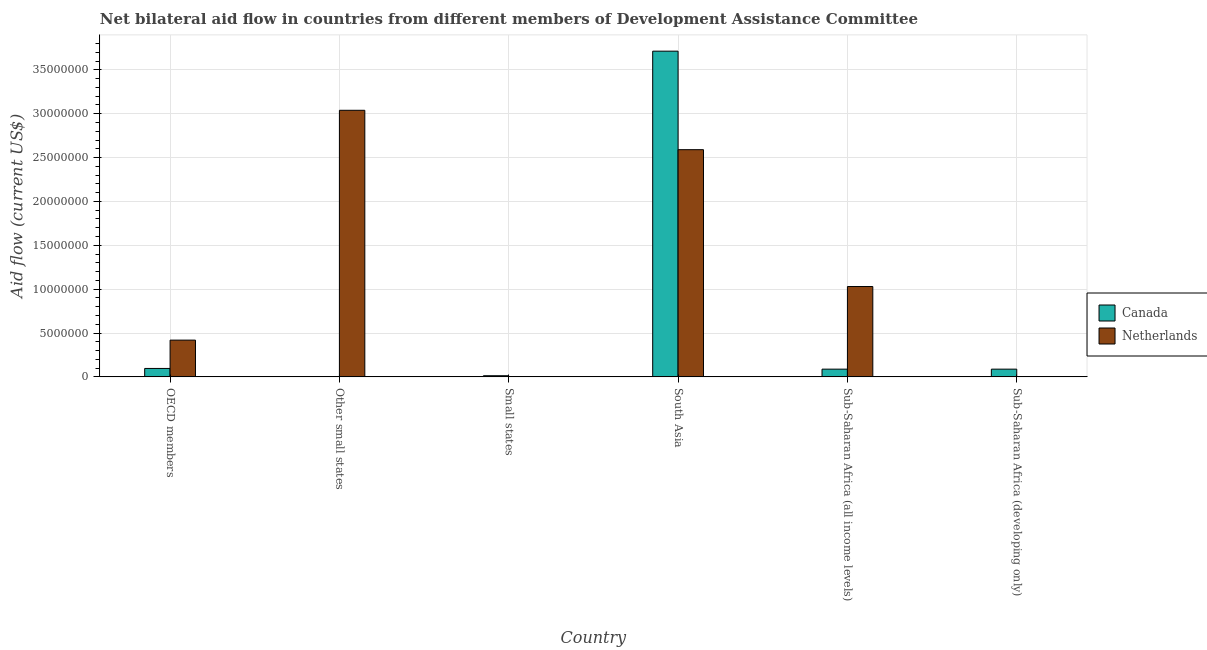How many different coloured bars are there?
Your response must be concise. 2. What is the label of the 2nd group of bars from the left?
Your response must be concise. Other small states. In how many cases, is the number of bars for a given country not equal to the number of legend labels?
Ensure brevity in your answer.  2. What is the amount of aid given by netherlands in Small states?
Offer a terse response. 0. Across all countries, what is the maximum amount of aid given by canada?
Provide a short and direct response. 3.71e+07. What is the total amount of aid given by netherlands in the graph?
Your answer should be very brief. 7.08e+07. What is the difference between the amount of aid given by canada in Small states and that in Sub-Saharan Africa (all income levels)?
Give a very brief answer. -7.50e+05. What is the difference between the amount of aid given by netherlands in Sub-Saharan Africa (developing only) and the amount of aid given by canada in South Asia?
Ensure brevity in your answer.  -3.71e+07. What is the average amount of aid given by canada per country?
Provide a succinct answer. 6.67e+06. What is the difference between the amount of aid given by canada and amount of aid given by netherlands in Other small states?
Your response must be concise. -3.04e+07. What is the ratio of the amount of aid given by canada in Small states to that in Sub-Saharan Africa (developing only)?
Provide a short and direct response. 0.15. Is the amount of aid given by canada in Sub-Saharan Africa (all income levels) less than that in Sub-Saharan Africa (developing only)?
Your answer should be very brief. No. Is the difference between the amount of aid given by netherlands in OECD members and Other small states greater than the difference between the amount of aid given by canada in OECD members and Other small states?
Your answer should be compact. No. What is the difference between the highest and the second highest amount of aid given by canada?
Keep it short and to the point. 3.62e+07. What is the difference between the highest and the lowest amount of aid given by canada?
Your response must be concise. 3.71e+07. In how many countries, is the amount of aid given by canada greater than the average amount of aid given by canada taken over all countries?
Offer a very short reply. 1. Is the sum of the amount of aid given by canada in Small states and Sub-Saharan Africa (developing only) greater than the maximum amount of aid given by netherlands across all countries?
Your answer should be compact. No. What is the difference between two consecutive major ticks on the Y-axis?
Ensure brevity in your answer.  5.00e+06. How many legend labels are there?
Your answer should be compact. 2. What is the title of the graph?
Make the answer very short. Net bilateral aid flow in countries from different members of Development Assistance Committee. What is the label or title of the X-axis?
Provide a succinct answer. Country. What is the Aid flow (current US$) in Canada in OECD members?
Your response must be concise. 9.60e+05. What is the Aid flow (current US$) in Netherlands in OECD members?
Your response must be concise. 4.19e+06. What is the Aid flow (current US$) in Netherlands in Other small states?
Your answer should be compact. 3.04e+07. What is the Aid flow (current US$) in Canada in Small states?
Make the answer very short. 1.30e+05. What is the Aid flow (current US$) of Netherlands in Small states?
Make the answer very short. 0. What is the Aid flow (current US$) in Canada in South Asia?
Your answer should be very brief. 3.71e+07. What is the Aid flow (current US$) of Netherlands in South Asia?
Provide a succinct answer. 2.59e+07. What is the Aid flow (current US$) in Canada in Sub-Saharan Africa (all income levels)?
Offer a very short reply. 8.80e+05. What is the Aid flow (current US$) of Netherlands in Sub-Saharan Africa (all income levels)?
Provide a short and direct response. 1.03e+07. What is the Aid flow (current US$) in Canada in Sub-Saharan Africa (developing only)?
Offer a very short reply. 8.80e+05. What is the Aid flow (current US$) in Netherlands in Sub-Saharan Africa (developing only)?
Provide a succinct answer. 0. Across all countries, what is the maximum Aid flow (current US$) of Canada?
Keep it short and to the point. 3.71e+07. Across all countries, what is the maximum Aid flow (current US$) in Netherlands?
Give a very brief answer. 3.04e+07. Across all countries, what is the minimum Aid flow (current US$) of Canada?
Offer a terse response. 3.00e+04. Across all countries, what is the minimum Aid flow (current US$) in Netherlands?
Your response must be concise. 0. What is the total Aid flow (current US$) of Canada in the graph?
Provide a succinct answer. 4.00e+07. What is the total Aid flow (current US$) in Netherlands in the graph?
Make the answer very short. 7.08e+07. What is the difference between the Aid flow (current US$) in Canada in OECD members and that in Other small states?
Ensure brevity in your answer.  9.30e+05. What is the difference between the Aid flow (current US$) of Netherlands in OECD members and that in Other small states?
Keep it short and to the point. -2.62e+07. What is the difference between the Aid flow (current US$) in Canada in OECD members and that in Small states?
Make the answer very short. 8.30e+05. What is the difference between the Aid flow (current US$) of Canada in OECD members and that in South Asia?
Your answer should be compact. -3.62e+07. What is the difference between the Aid flow (current US$) of Netherlands in OECD members and that in South Asia?
Keep it short and to the point. -2.17e+07. What is the difference between the Aid flow (current US$) in Canada in OECD members and that in Sub-Saharan Africa (all income levels)?
Provide a short and direct response. 8.00e+04. What is the difference between the Aid flow (current US$) of Netherlands in OECD members and that in Sub-Saharan Africa (all income levels)?
Keep it short and to the point. -6.11e+06. What is the difference between the Aid flow (current US$) in Canada in Other small states and that in Small states?
Your response must be concise. -1.00e+05. What is the difference between the Aid flow (current US$) in Canada in Other small states and that in South Asia?
Offer a terse response. -3.71e+07. What is the difference between the Aid flow (current US$) in Netherlands in Other small states and that in South Asia?
Give a very brief answer. 4.49e+06. What is the difference between the Aid flow (current US$) in Canada in Other small states and that in Sub-Saharan Africa (all income levels)?
Ensure brevity in your answer.  -8.50e+05. What is the difference between the Aid flow (current US$) in Netherlands in Other small states and that in Sub-Saharan Africa (all income levels)?
Your response must be concise. 2.01e+07. What is the difference between the Aid flow (current US$) of Canada in Other small states and that in Sub-Saharan Africa (developing only)?
Make the answer very short. -8.50e+05. What is the difference between the Aid flow (current US$) of Canada in Small states and that in South Asia?
Make the answer very short. -3.70e+07. What is the difference between the Aid flow (current US$) of Canada in Small states and that in Sub-Saharan Africa (all income levels)?
Keep it short and to the point. -7.50e+05. What is the difference between the Aid flow (current US$) of Canada in Small states and that in Sub-Saharan Africa (developing only)?
Ensure brevity in your answer.  -7.50e+05. What is the difference between the Aid flow (current US$) in Canada in South Asia and that in Sub-Saharan Africa (all income levels)?
Ensure brevity in your answer.  3.62e+07. What is the difference between the Aid flow (current US$) of Netherlands in South Asia and that in Sub-Saharan Africa (all income levels)?
Provide a succinct answer. 1.56e+07. What is the difference between the Aid flow (current US$) of Canada in South Asia and that in Sub-Saharan Africa (developing only)?
Give a very brief answer. 3.62e+07. What is the difference between the Aid flow (current US$) in Canada in Sub-Saharan Africa (all income levels) and that in Sub-Saharan Africa (developing only)?
Provide a short and direct response. 0. What is the difference between the Aid flow (current US$) in Canada in OECD members and the Aid flow (current US$) in Netherlands in Other small states?
Your answer should be very brief. -2.94e+07. What is the difference between the Aid flow (current US$) in Canada in OECD members and the Aid flow (current US$) in Netherlands in South Asia?
Keep it short and to the point. -2.49e+07. What is the difference between the Aid flow (current US$) of Canada in OECD members and the Aid flow (current US$) of Netherlands in Sub-Saharan Africa (all income levels)?
Provide a short and direct response. -9.34e+06. What is the difference between the Aid flow (current US$) of Canada in Other small states and the Aid flow (current US$) of Netherlands in South Asia?
Provide a succinct answer. -2.59e+07. What is the difference between the Aid flow (current US$) of Canada in Other small states and the Aid flow (current US$) of Netherlands in Sub-Saharan Africa (all income levels)?
Provide a succinct answer. -1.03e+07. What is the difference between the Aid flow (current US$) of Canada in Small states and the Aid flow (current US$) of Netherlands in South Asia?
Give a very brief answer. -2.58e+07. What is the difference between the Aid flow (current US$) in Canada in Small states and the Aid flow (current US$) in Netherlands in Sub-Saharan Africa (all income levels)?
Give a very brief answer. -1.02e+07. What is the difference between the Aid flow (current US$) in Canada in South Asia and the Aid flow (current US$) in Netherlands in Sub-Saharan Africa (all income levels)?
Give a very brief answer. 2.68e+07. What is the average Aid flow (current US$) in Canada per country?
Offer a very short reply. 6.67e+06. What is the average Aid flow (current US$) in Netherlands per country?
Your answer should be very brief. 1.18e+07. What is the difference between the Aid flow (current US$) in Canada and Aid flow (current US$) in Netherlands in OECD members?
Provide a short and direct response. -3.23e+06. What is the difference between the Aid flow (current US$) in Canada and Aid flow (current US$) in Netherlands in Other small states?
Make the answer very short. -3.04e+07. What is the difference between the Aid flow (current US$) of Canada and Aid flow (current US$) of Netherlands in South Asia?
Your answer should be compact. 1.12e+07. What is the difference between the Aid flow (current US$) in Canada and Aid flow (current US$) in Netherlands in Sub-Saharan Africa (all income levels)?
Your answer should be very brief. -9.42e+06. What is the ratio of the Aid flow (current US$) in Canada in OECD members to that in Other small states?
Make the answer very short. 32. What is the ratio of the Aid flow (current US$) in Netherlands in OECD members to that in Other small states?
Offer a terse response. 0.14. What is the ratio of the Aid flow (current US$) in Canada in OECD members to that in Small states?
Make the answer very short. 7.38. What is the ratio of the Aid flow (current US$) in Canada in OECD members to that in South Asia?
Provide a succinct answer. 0.03. What is the ratio of the Aid flow (current US$) of Netherlands in OECD members to that in South Asia?
Ensure brevity in your answer.  0.16. What is the ratio of the Aid flow (current US$) in Netherlands in OECD members to that in Sub-Saharan Africa (all income levels)?
Your response must be concise. 0.41. What is the ratio of the Aid flow (current US$) of Canada in Other small states to that in Small states?
Give a very brief answer. 0.23. What is the ratio of the Aid flow (current US$) of Canada in Other small states to that in South Asia?
Provide a short and direct response. 0. What is the ratio of the Aid flow (current US$) in Netherlands in Other small states to that in South Asia?
Offer a terse response. 1.17. What is the ratio of the Aid flow (current US$) in Canada in Other small states to that in Sub-Saharan Africa (all income levels)?
Keep it short and to the point. 0.03. What is the ratio of the Aid flow (current US$) of Netherlands in Other small states to that in Sub-Saharan Africa (all income levels)?
Your answer should be compact. 2.95. What is the ratio of the Aid flow (current US$) in Canada in Other small states to that in Sub-Saharan Africa (developing only)?
Provide a succinct answer. 0.03. What is the ratio of the Aid flow (current US$) of Canada in Small states to that in South Asia?
Your response must be concise. 0. What is the ratio of the Aid flow (current US$) in Canada in Small states to that in Sub-Saharan Africa (all income levels)?
Provide a succinct answer. 0.15. What is the ratio of the Aid flow (current US$) in Canada in Small states to that in Sub-Saharan Africa (developing only)?
Ensure brevity in your answer.  0.15. What is the ratio of the Aid flow (current US$) in Canada in South Asia to that in Sub-Saharan Africa (all income levels)?
Offer a very short reply. 42.19. What is the ratio of the Aid flow (current US$) of Netherlands in South Asia to that in Sub-Saharan Africa (all income levels)?
Provide a short and direct response. 2.51. What is the ratio of the Aid flow (current US$) of Canada in South Asia to that in Sub-Saharan Africa (developing only)?
Make the answer very short. 42.19. What is the difference between the highest and the second highest Aid flow (current US$) of Canada?
Ensure brevity in your answer.  3.62e+07. What is the difference between the highest and the second highest Aid flow (current US$) in Netherlands?
Make the answer very short. 4.49e+06. What is the difference between the highest and the lowest Aid flow (current US$) of Canada?
Provide a succinct answer. 3.71e+07. What is the difference between the highest and the lowest Aid flow (current US$) of Netherlands?
Your answer should be compact. 3.04e+07. 